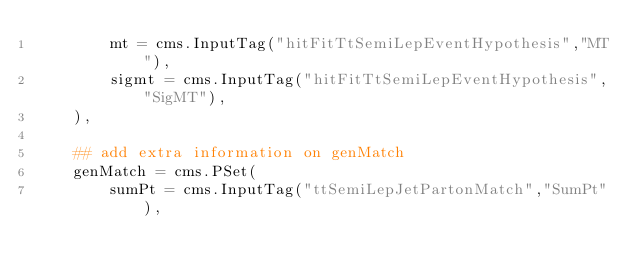Convert code to text. <code><loc_0><loc_0><loc_500><loc_500><_Python_>        mt = cms.InputTag("hitFitTtSemiLepEventHypothesis","MT"),
        sigmt = cms.InputTag("hitFitTtSemiLepEventHypothesis","SigMT"),
    ),

    ## add extra information on genMatch
    genMatch = cms.PSet(
        sumPt = cms.InputTag("ttSemiLepJetPartonMatch","SumPt"),</code> 